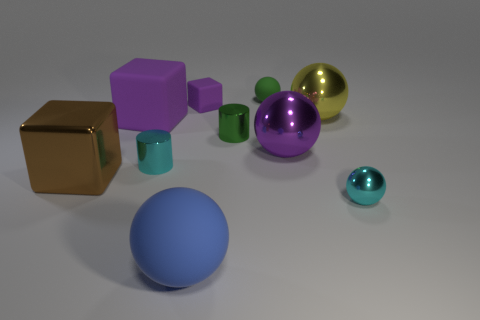There is a large purple object right of the purple rubber thing that is right of the big purple block; what is its shape?
Offer a terse response. Sphere. There is a purple metallic object to the right of the brown metal object; is it the same shape as the green shiny object?
Your answer should be compact. No. There is a cyan ball that is the same material as the brown thing; what is its size?
Your answer should be very brief. Small. How many objects are large purple things that are left of the big blue ball or objects right of the large brown shiny thing?
Make the answer very short. 9. Are there an equal number of matte cubes that are on the right side of the blue object and cyan objects on the left side of the tiny green rubber thing?
Your response must be concise. No. There is a small object in front of the brown thing; what is its color?
Keep it short and to the point. Cyan. Is the color of the large rubber block the same as the large shiny sphere in front of the tiny green shiny cylinder?
Make the answer very short. Yes. Is the number of yellow metallic spheres less than the number of brown rubber balls?
Offer a terse response. No. Is the color of the cube behind the big purple block the same as the large matte cube?
Ensure brevity in your answer.  Yes. How many purple blocks are the same size as the blue matte thing?
Offer a terse response. 1. 